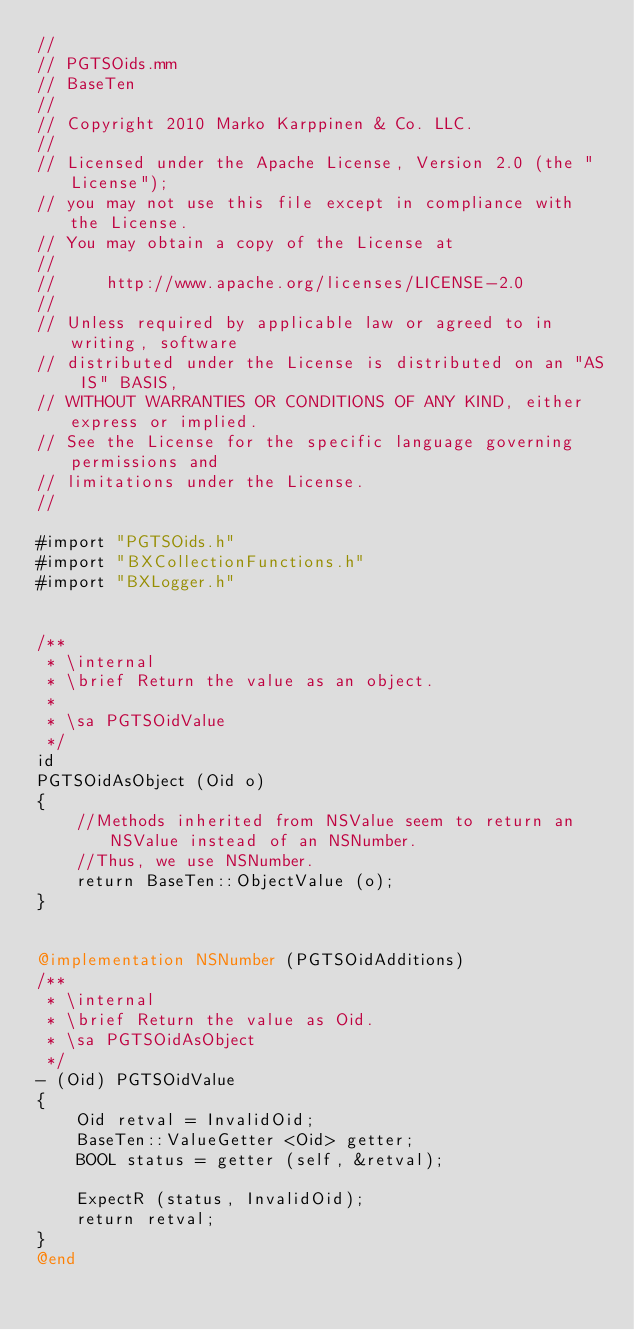<code> <loc_0><loc_0><loc_500><loc_500><_ObjectiveC_>//
// PGTSOids.mm
// BaseTen
//
// Copyright 2010 Marko Karppinen & Co. LLC.
// 
// Licensed under the Apache License, Version 2.0 (the "License");
// you may not use this file except in compliance with the License.
// You may obtain a copy of the License at
// 
//     http://www.apache.org/licenses/LICENSE-2.0
// 
// Unless required by applicable law or agreed to in writing, software
// distributed under the License is distributed on an "AS IS" BASIS,
// WITHOUT WARRANTIES OR CONDITIONS OF ANY KIND, either express or implied.
// See the License for the specific language governing permissions and
// limitations under the License.
//

#import "PGTSOids.h"
#import "BXCollectionFunctions.h"
#import "BXLogger.h"


/**
 * \internal
 * \brief Return the value as an object.
 *
 * \sa PGTSOidValue
 */
id 
PGTSOidAsObject (Oid o)
{
    //Methods inherited from NSValue seem to return an NSValue instead of an NSNumber.
	//Thus, we use NSNumber.
    return BaseTen::ObjectValue (o);
}


@implementation NSNumber (PGTSOidAdditions)
/**
 * \internal
 * \brief Return the value as Oid.
 * \sa PGTSOidAsObject
 */
- (Oid) PGTSOidValue
{
	Oid retval = InvalidOid;
	BaseTen::ValueGetter <Oid> getter;
	BOOL status = getter (self, &retval);
	
	ExpectR (status, InvalidOid);
	return retval;
}
@end
</code> 